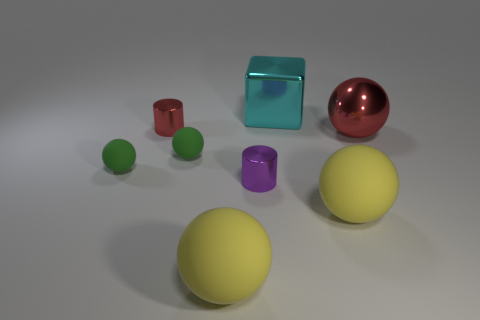Add 1 small cylinders. How many objects exist? 9 Subtract all shiny spheres. How many spheres are left? 4 Subtract all green cubes. How many green spheres are left? 2 Subtract 0 brown cylinders. How many objects are left? 8 Subtract all cylinders. How many objects are left? 6 Subtract 1 cylinders. How many cylinders are left? 1 Subtract all blue cylinders. Subtract all yellow spheres. How many cylinders are left? 2 Subtract all brown cylinders. Subtract all small red metallic objects. How many objects are left? 7 Add 7 red objects. How many red objects are left? 9 Add 1 small green rubber objects. How many small green rubber objects exist? 3 